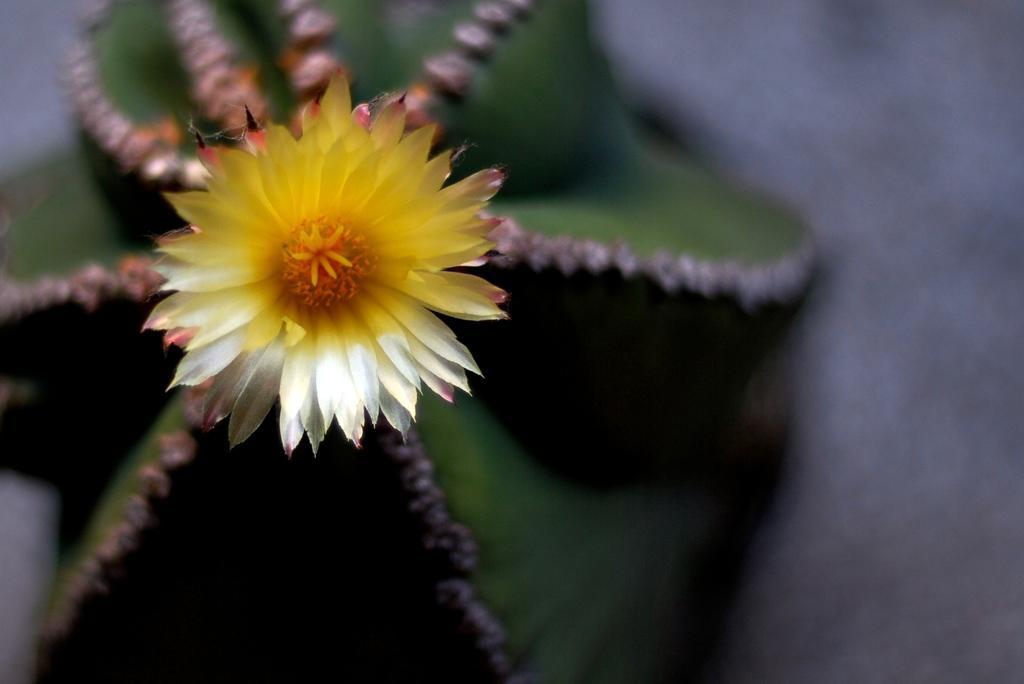How would you summarize this image in a sentence or two? In this picture It looks like a plant and I can see a flower. 